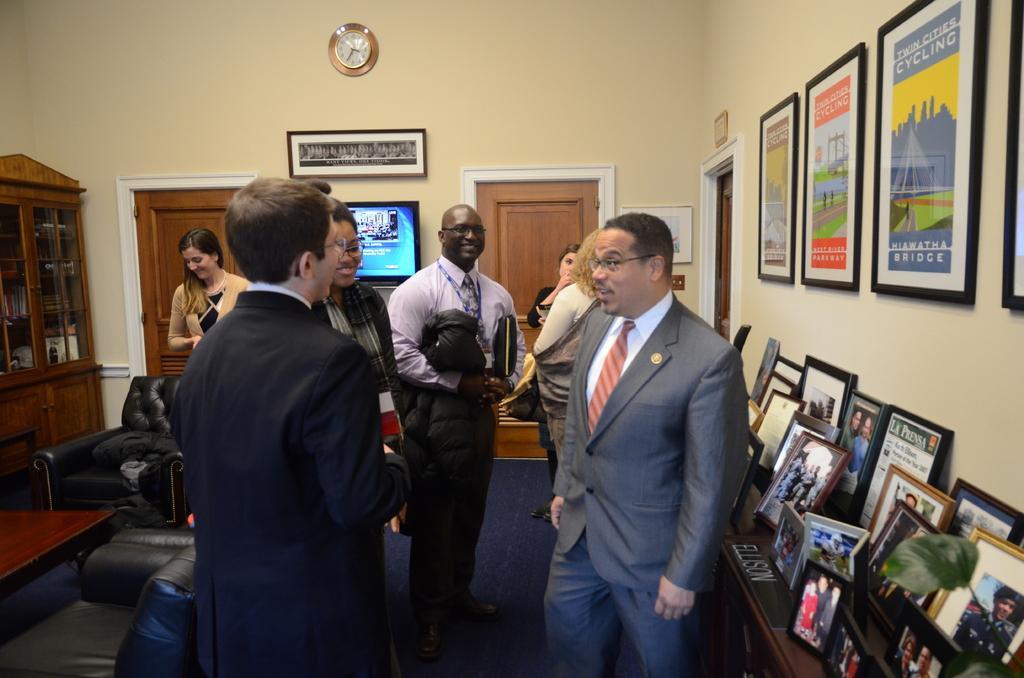Please provide a concise description of this image. In this picture we can see few persons standing and talking and smiling each other. On the background we can see doors, photo frames, television and a clock over the wall. This is a cupboard. Here we can see photo frames. These are also photo frames on the table. These are sofas and chairs. 